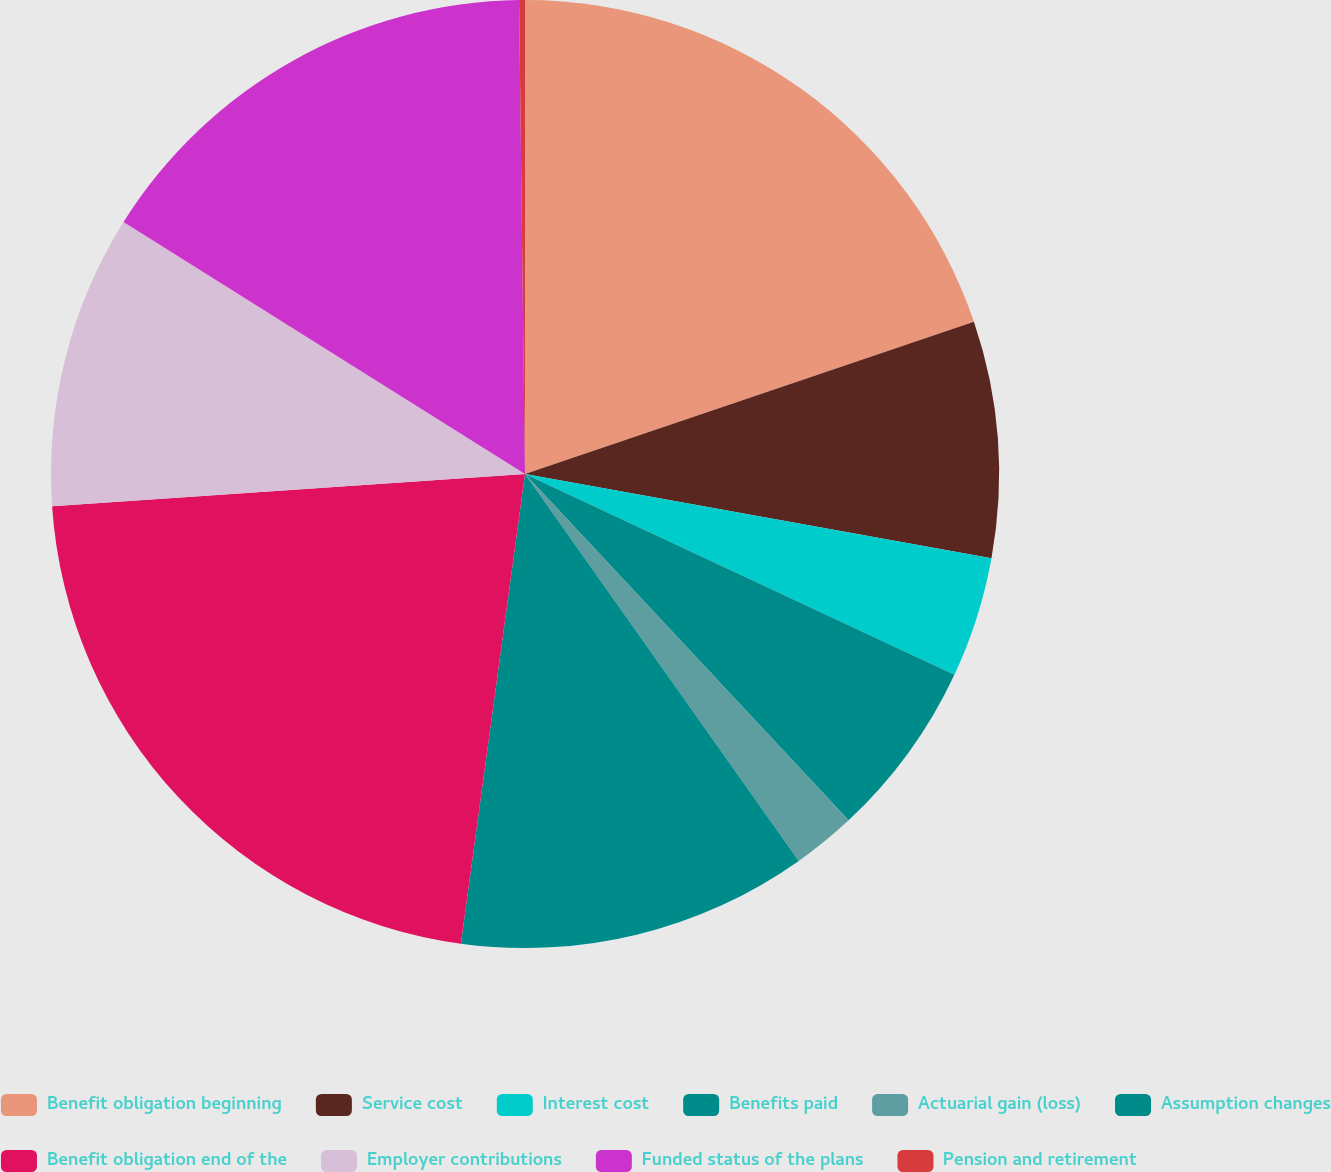Convert chart. <chart><loc_0><loc_0><loc_500><loc_500><pie_chart><fcel>Benefit obligation beginning<fcel>Service cost<fcel>Interest cost<fcel>Benefits paid<fcel>Actuarial gain (loss)<fcel>Assumption changes<fcel>Benefit obligation end of the<fcel>Employer contributions<fcel>Funded status of the plans<fcel>Pension and retirement<nl><fcel>19.8%<fcel>8.04%<fcel>4.12%<fcel>6.08%<fcel>2.16%<fcel>11.96%<fcel>21.76%<fcel>10.0%<fcel>15.88%<fcel>0.2%<nl></chart> 